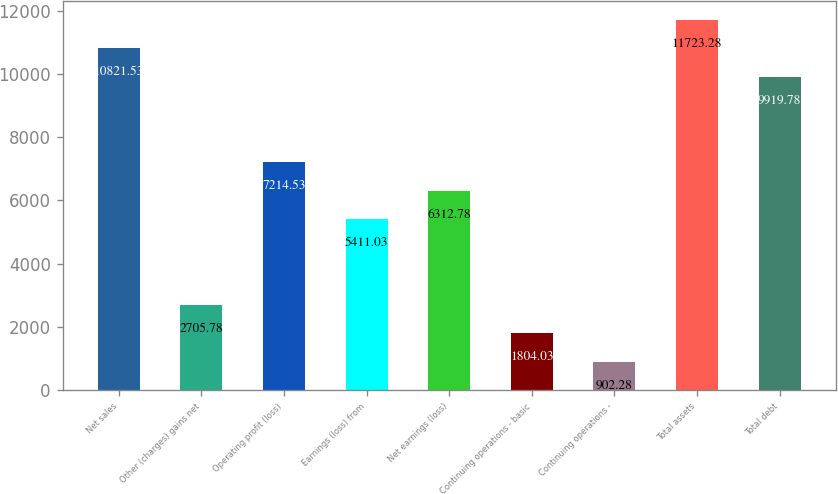Convert chart to OTSL. <chart><loc_0><loc_0><loc_500><loc_500><bar_chart><fcel>Net sales<fcel>Other (charges) gains net<fcel>Operating profit (loss)<fcel>Earnings (loss) from<fcel>Net earnings (loss)<fcel>Continuing operations - basic<fcel>Continuing operations -<fcel>Total assets<fcel>Total debt<nl><fcel>10821.5<fcel>2705.78<fcel>7214.53<fcel>5411.03<fcel>6312.78<fcel>1804.03<fcel>902.28<fcel>11723.3<fcel>9919.78<nl></chart> 